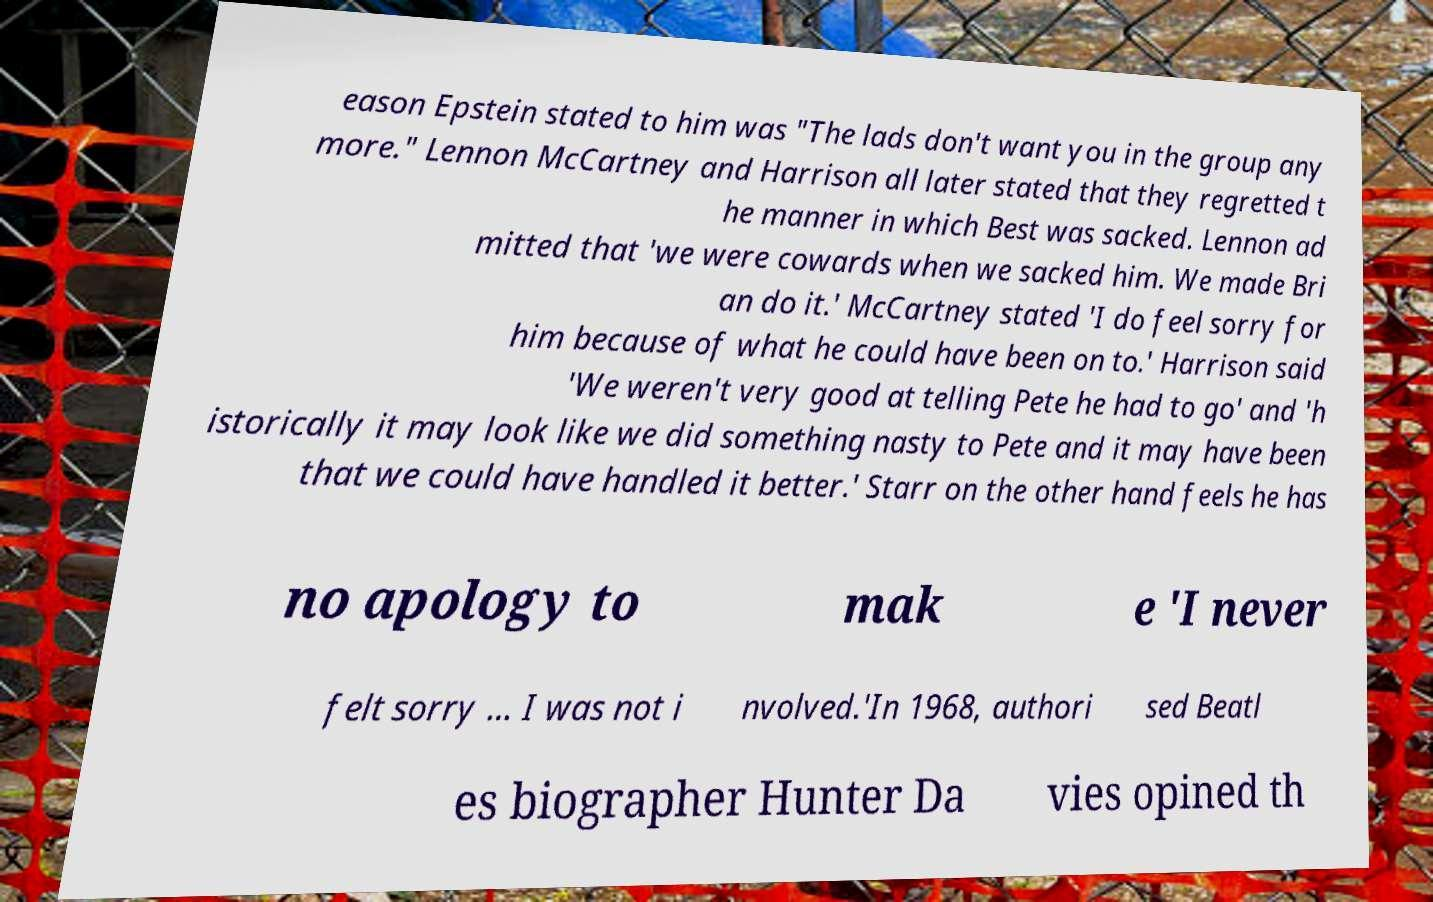Could you extract and type out the text from this image? eason Epstein stated to him was "The lads don't want you in the group any more." Lennon McCartney and Harrison all later stated that they regretted t he manner in which Best was sacked. Lennon ad mitted that 'we were cowards when we sacked him. We made Bri an do it.' McCartney stated 'I do feel sorry for him because of what he could have been on to.' Harrison said 'We weren't very good at telling Pete he had to go' and 'h istorically it may look like we did something nasty to Pete and it may have been that we could have handled it better.' Starr on the other hand feels he has no apology to mak e 'I never felt sorry … I was not i nvolved.'In 1968, authori sed Beatl es biographer Hunter Da vies opined th 